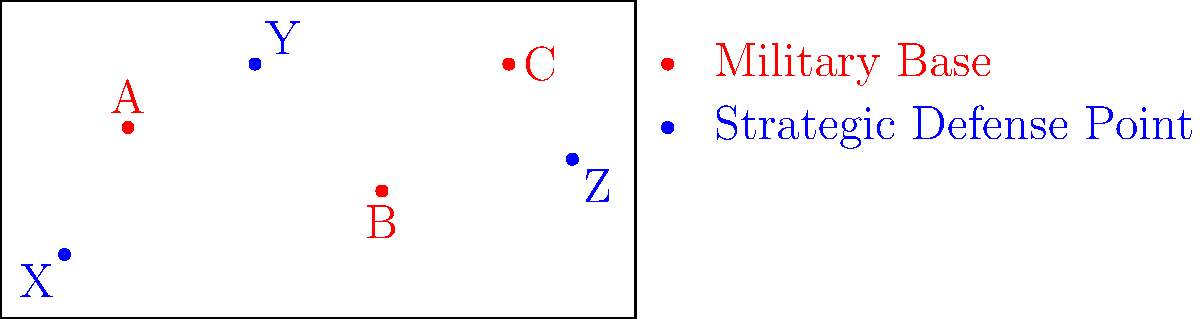Given the world map highlighting global military presence and strategic defense points, calculate the total power output required to maintain constant communication between all military bases (A, B, C) and strategic defense points (X, Y, Z). Assume the power output is proportional to the square of the distance between points, with a constant of proportionality $k = 0.1 \text{ W/unit}^2$. Express your answer in watts (W). To solve this problem, we need to follow these steps:

1) Calculate the distances between each military base and each strategic defense point.
2) Square each distance.
3) Multiply each squared distance by the constant of proportionality $k$.
4) Sum all the results.

Let's assume the map is on a 100x50 grid for calculation purposes.

Distances:
AX: $\sqrt{(20-10)^2 + (30-10)^2} = \sqrt{500} \approx 22.36$
AY: $\sqrt{(20-40)^2 + (30-40)^2} = \sqrt{500} \approx 22.36$
AZ: $\sqrt{(20-90)^2 + (30-25)^2} = \sqrt{5025} \approx 70.89$
BX: $\sqrt{(60-10)^2 + (20-10)^2} = \sqrt{2600} \approx 50.99$
BY: $\sqrt{(60-40)^2 + (20-40)^2} = \sqrt{800} \approx 28.28$
BZ: $\sqrt{(60-90)^2 + (20-25)^2} = \sqrt{925} \approx 30.41$
CX: $\sqrt{(80-10)^2 + (40-10)^2} = \sqrt{5800} \approx 76.16$
CY: $\sqrt{(80-40)^2 + (40-40)^2} = 40$
CZ: $\sqrt{(80-90)^2 + (40-25)^2} = \sqrt{325} \approx 18.03$

Now, let's square each distance and multiply by $k = 0.1$:

AX: $22.36^2 * 0.1 = 50.00$ W
AY: $22.36^2 * 0.1 = 50.00$ W
AZ: $70.89^2 * 0.1 = 502.50$ W
BX: $50.99^2 * 0.1 = 260.00$ W
BY: $28.28^2 * 0.1 = 80.00$ W
BZ: $30.41^2 * 0.1 = 92.50$ W
CX: $76.16^2 * 0.1 = 580.00$ W
CY: $40^2 * 0.1 = 160.00$ W
CZ: $18.03^2 * 0.1 = 32.50$ W

Sum all the results:
$50.00 + 50.00 + 502.50 + 260.00 + 80.00 + 92.50 + 580.00 + 160.00 + 32.50 = 1807.50$ W

Therefore, the total power output required is approximately 1807.50 W.
Answer: 1807.50 W 